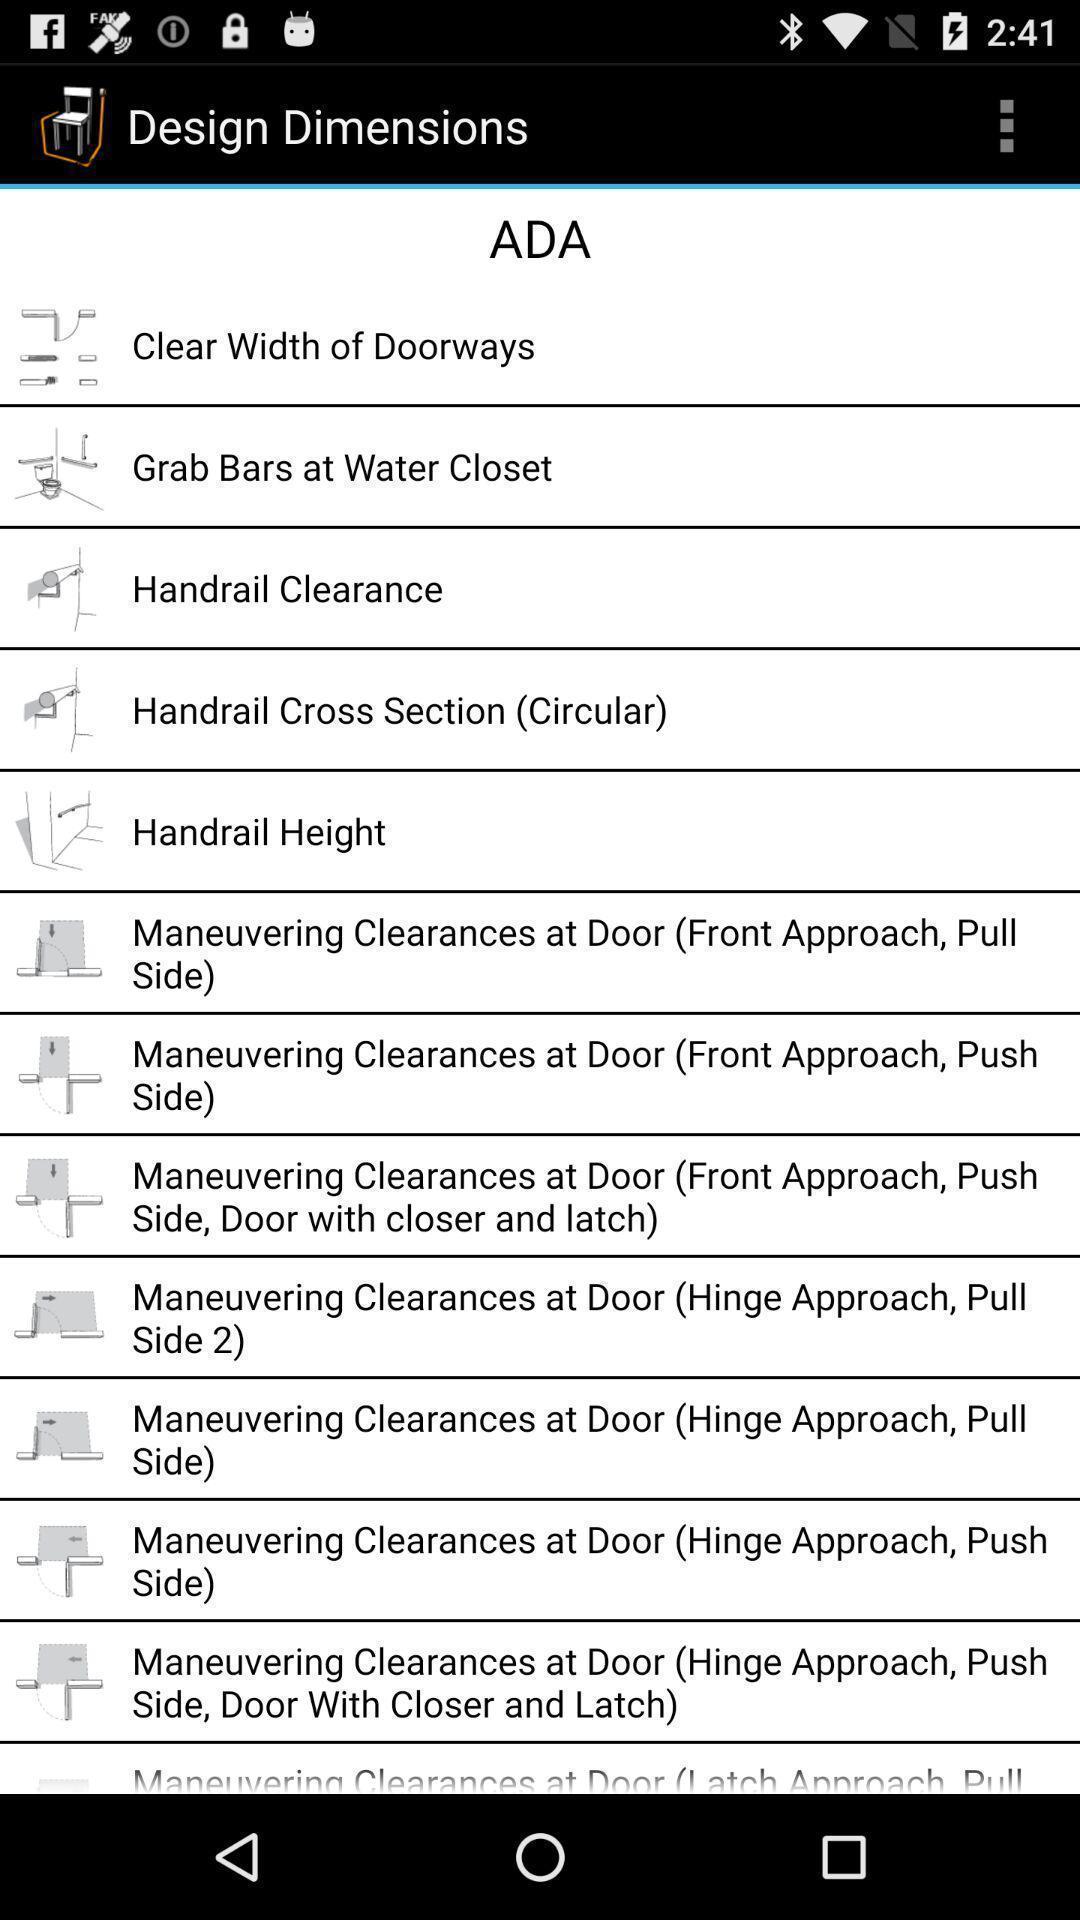Give me a narrative description of this picture. Screen displaying multiple door images with description. 